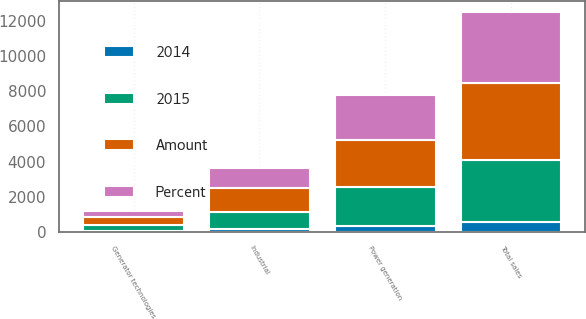<chart> <loc_0><loc_0><loc_500><loc_500><stacked_bar_chart><ecel><fcel>Power generation<fcel>Industrial<fcel>Generator technologies<fcel>Total sales<nl><fcel>2015<fcel>2235<fcel>963<fcel>319<fcel>3517<nl><fcel>Percent<fcel>2570<fcel>1137<fcel>360<fcel>4067<nl><fcel>Amount<fcel>2633<fcel>1331<fcel>450<fcel>4414<nl><fcel>2014<fcel>335<fcel>174<fcel>41<fcel>550<nl></chart> 